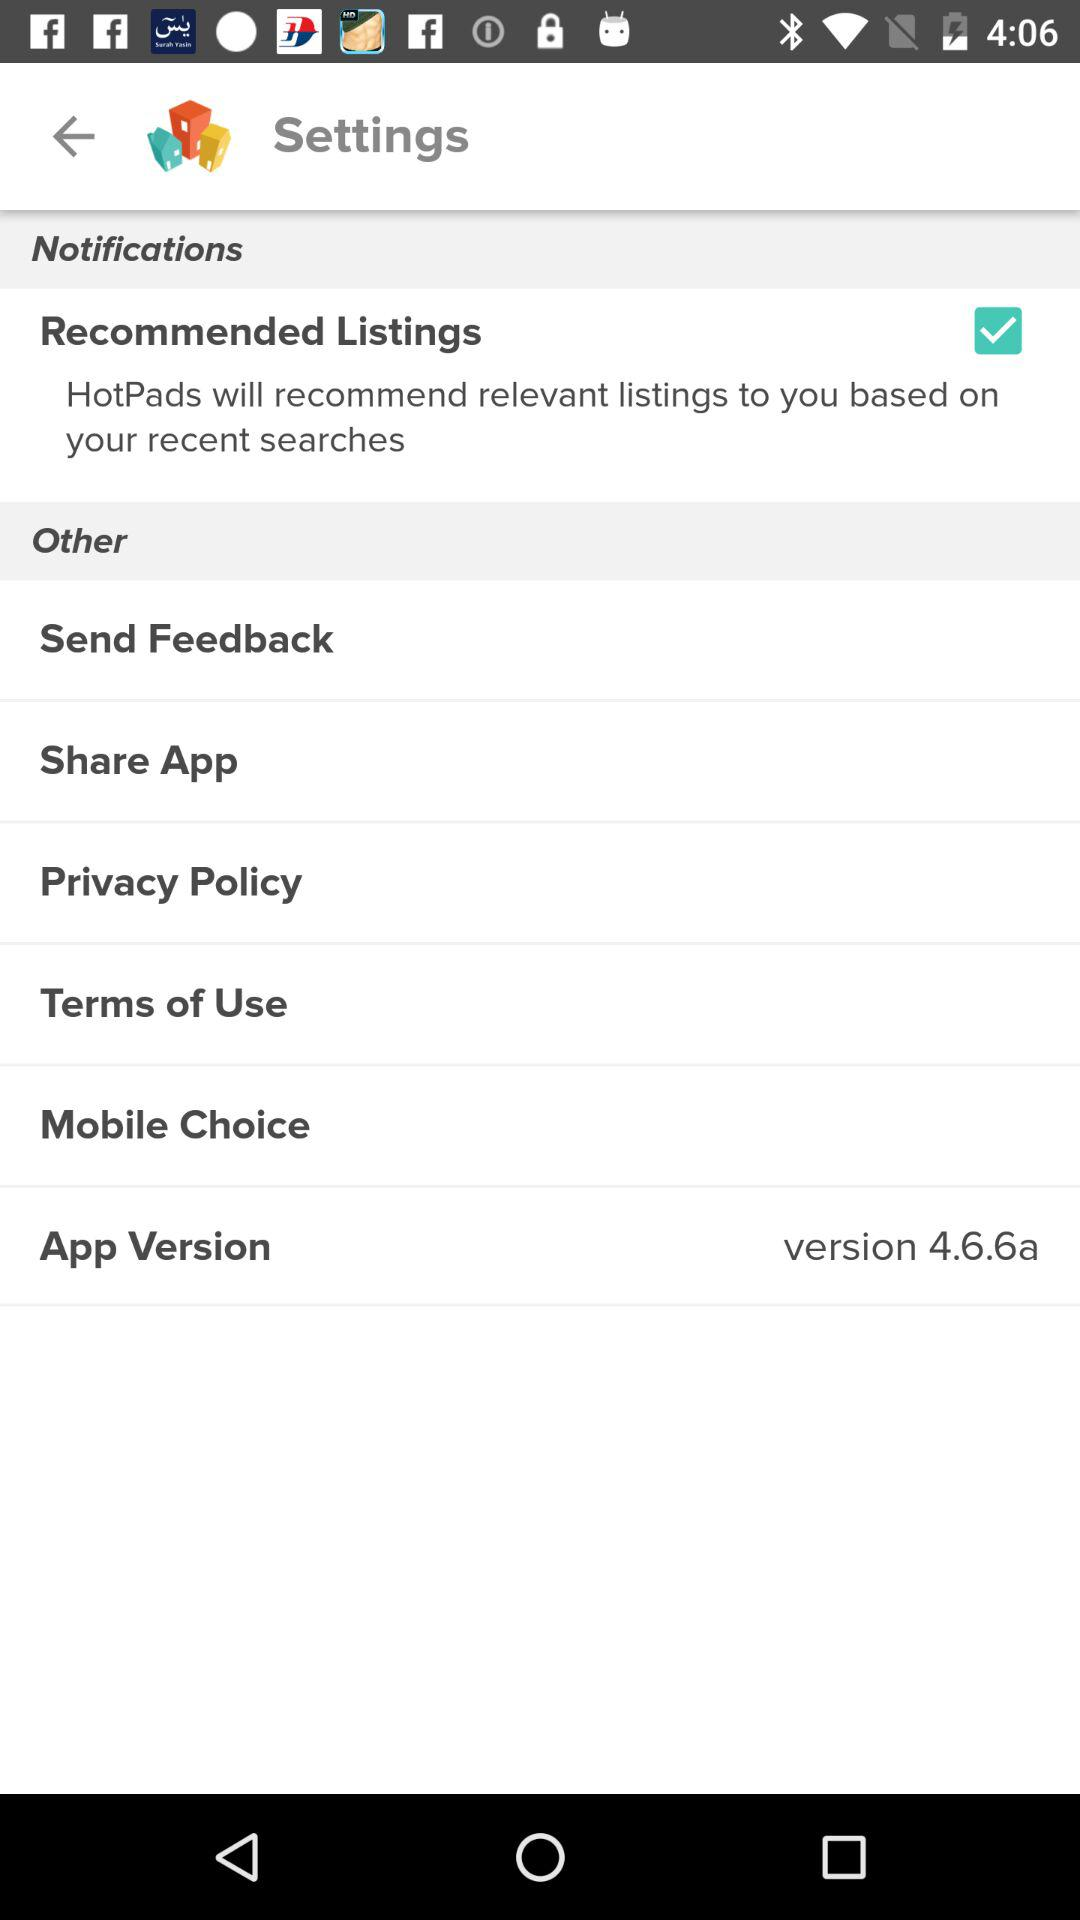What is the status of "Recommended Listings"? The status of "Recommended Listings" is "on". 